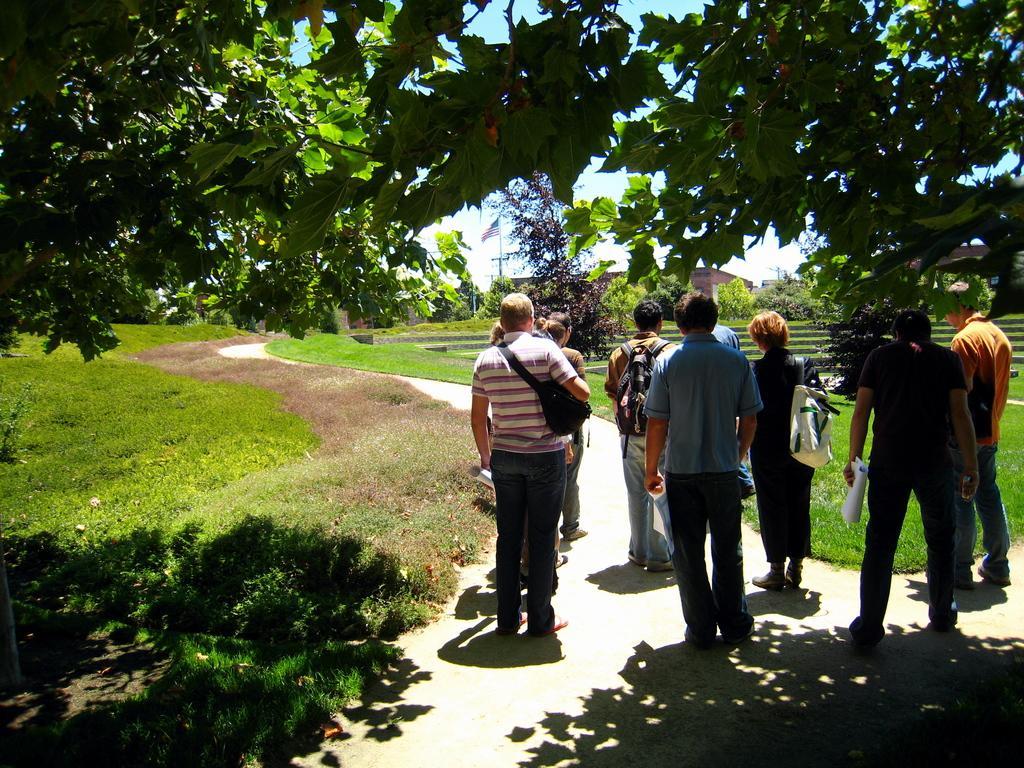In one or two sentences, can you explain what this image depicts? In this image we can see persons from the backside who are standing on the ground. In the background we can see bushes, grass, trees, flag, flag post, buildings and sky. 